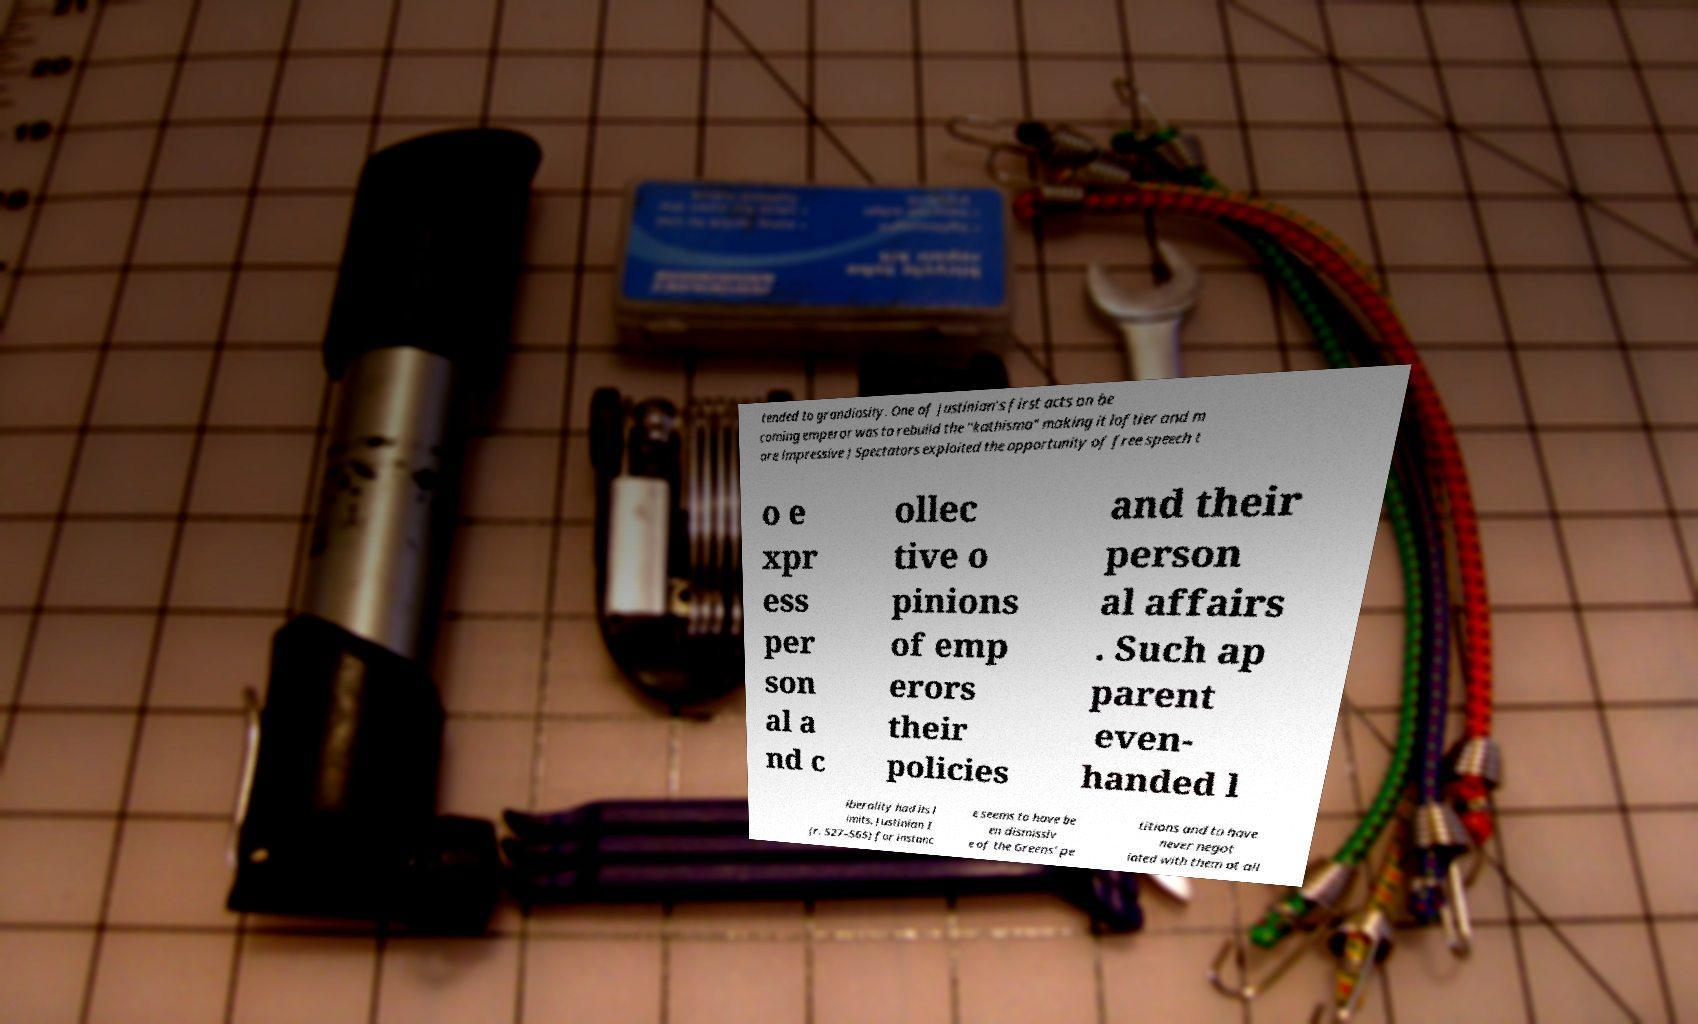Can you read and provide the text displayed in the image?This photo seems to have some interesting text. Can you extract and type it out for me? tended to grandiosity. One of Justinian's first acts on be coming emperor was to rebuild the "kathisma" making it loftier and m ore impressive ) Spectators exploited the opportunity of free speech t o e xpr ess per son al a nd c ollec tive o pinions of emp erors their policies and their person al affairs . Such ap parent even- handed l iberality had its l imits. Justinian I (r. 527–565) for instanc e seems to have be en dismissiv e of the Greens' pe titions and to have never negot iated with them at all 